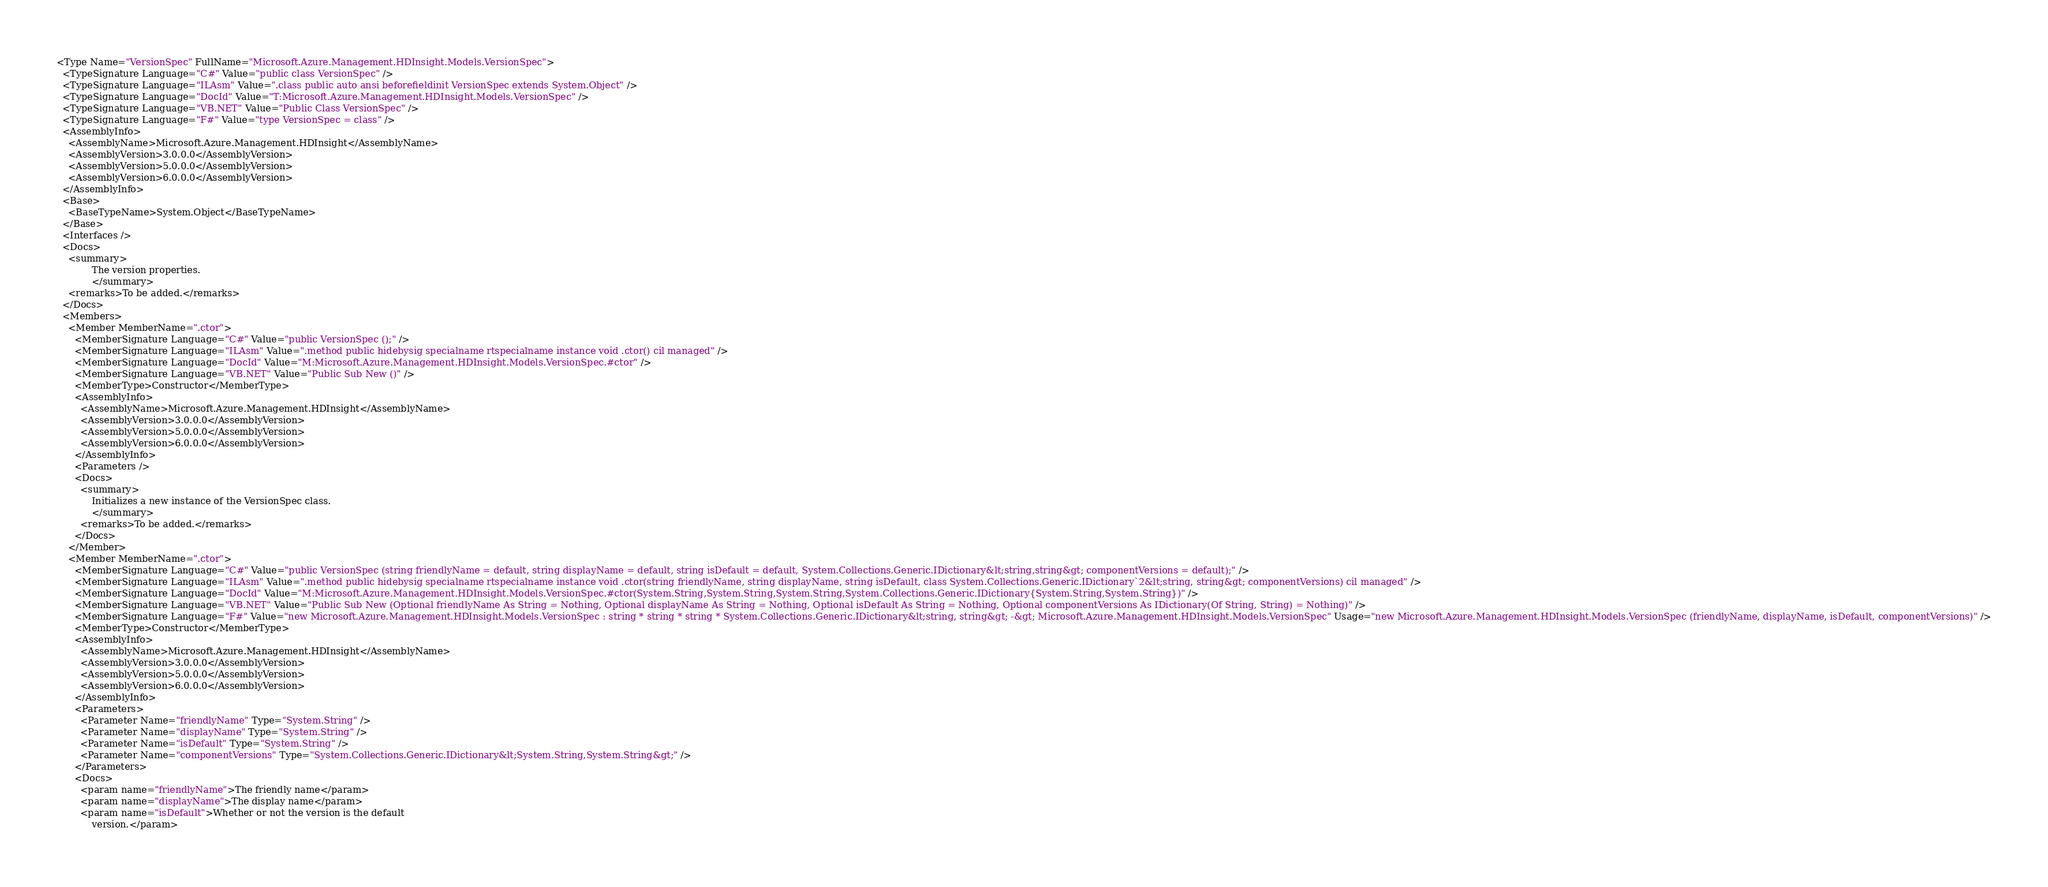<code> <loc_0><loc_0><loc_500><loc_500><_XML_><Type Name="VersionSpec" FullName="Microsoft.Azure.Management.HDInsight.Models.VersionSpec">
  <TypeSignature Language="C#" Value="public class VersionSpec" />
  <TypeSignature Language="ILAsm" Value=".class public auto ansi beforefieldinit VersionSpec extends System.Object" />
  <TypeSignature Language="DocId" Value="T:Microsoft.Azure.Management.HDInsight.Models.VersionSpec" />
  <TypeSignature Language="VB.NET" Value="Public Class VersionSpec" />
  <TypeSignature Language="F#" Value="type VersionSpec = class" />
  <AssemblyInfo>
    <AssemblyName>Microsoft.Azure.Management.HDInsight</AssemblyName>
    <AssemblyVersion>3.0.0.0</AssemblyVersion>
    <AssemblyVersion>5.0.0.0</AssemblyVersion>
    <AssemblyVersion>6.0.0.0</AssemblyVersion>
  </AssemblyInfo>
  <Base>
    <BaseTypeName>System.Object</BaseTypeName>
  </Base>
  <Interfaces />
  <Docs>
    <summary>
            The version properties.
            </summary>
    <remarks>To be added.</remarks>
  </Docs>
  <Members>
    <Member MemberName=".ctor">
      <MemberSignature Language="C#" Value="public VersionSpec ();" />
      <MemberSignature Language="ILAsm" Value=".method public hidebysig specialname rtspecialname instance void .ctor() cil managed" />
      <MemberSignature Language="DocId" Value="M:Microsoft.Azure.Management.HDInsight.Models.VersionSpec.#ctor" />
      <MemberSignature Language="VB.NET" Value="Public Sub New ()" />
      <MemberType>Constructor</MemberType>
      <AssemblyInfo>
        <AssemblyName>Microsoft.Azure.Management.HDInsight</AssemblyName>
        <AssemblyVersion>3.0.0.0</AssemblyVersion>
        <AssemblyVersion>5.0.0.0</AssemblyVersion>
        <AssemblyVersion>6.0.0.0</AssemblyVersion>
      </AssemblyInfo>
      <Parameters />
      <Docs>
        <summary>
            Initializes a new instance of the VersionSpec class.
            </summary>
        <remarks>To be added.</remarks>
      </Docs>
    </Member>
    <Member MemberName=".ctor">
      <MemberSignature Language="C#" Value="public VersionSpec (string friendlyName = default, string displayName = default, string isDefault = default, System.Collections.Generic.IDictionary&lt;string,string&gt; componentVersions = default);" />
      <MemberSignature Language="ILAsm" Value=".method public hidebysig specialname rtspecialname instance void .ctor(string friendlyName, string displayName, string isDefault, class System.Collections.Generic.IDictionary`2&lt;string, string&gt; componentVersions) cil managed" />
      <MemberSignature Language="DocId" Value="M:Microsoft.Azure.Management.HDInsight.Models.VersionSpec.#ctor(System.String,System.String,System.String,System.Collections.Generic.IDictionary{System.String,System.String})" />
      <MemberSignature Language="VB.NET" Value="Public Sub New (Optional friendlyName As String = Nothing, Optional displayName As String = Nothing, Optional isDefault As String = Nothing, Optional componentVersions As IDictionary(Of String, String) = Nothing)" />
      <MemberSignature Language="F#" Value="new Microsoft.Azure.Management.HDInsight.Models.VersionSpec : string * string * string * System.Collections.Generic.IDictionary&lt;string, string&gt; -&gt; Microsoft.Azure.Management.HDInsight.Models.VersionSpec" Usage="new Microsoft.Azure.Management.HDInsight.Models.VersionSpec (friendlyName, displayName, isDefault, componentVersions)" />
      <MemberType>Constructor</MemberType>
      <AssemblyInfo>
        <AssemblyName>Microsoft.Azure.Management.HDInsight</AssemblyName>
        <AssemblyVersion>3.0.0.0</AssemblyVersion>
        <AssemblyVersion>5.0.0.0</AssemblyVersion>
        <AssemblyVersion>6.0.0.0</AssemblyVersion>
      </AssemblyInfo>
      <Parameters>
        <Parameter Name="friendlyName" Type="System.String" />
        <Parameter Name="displayName" Type="System.String" />
        <Parameter Name="isDefault" Type="System.String" />
        <Parameter Name="componentVersions" Type="System.Collections.Generic.IDictionary&lt;System.String,System.String&gt;" />
      </Parameters>
      <Docs>
        <param name="friendlyName">The friendly name</param>
        <param name="displayName">The display name</param>
        <param name="isDefault">Whether or not the version is the default
            version.</param></code> 